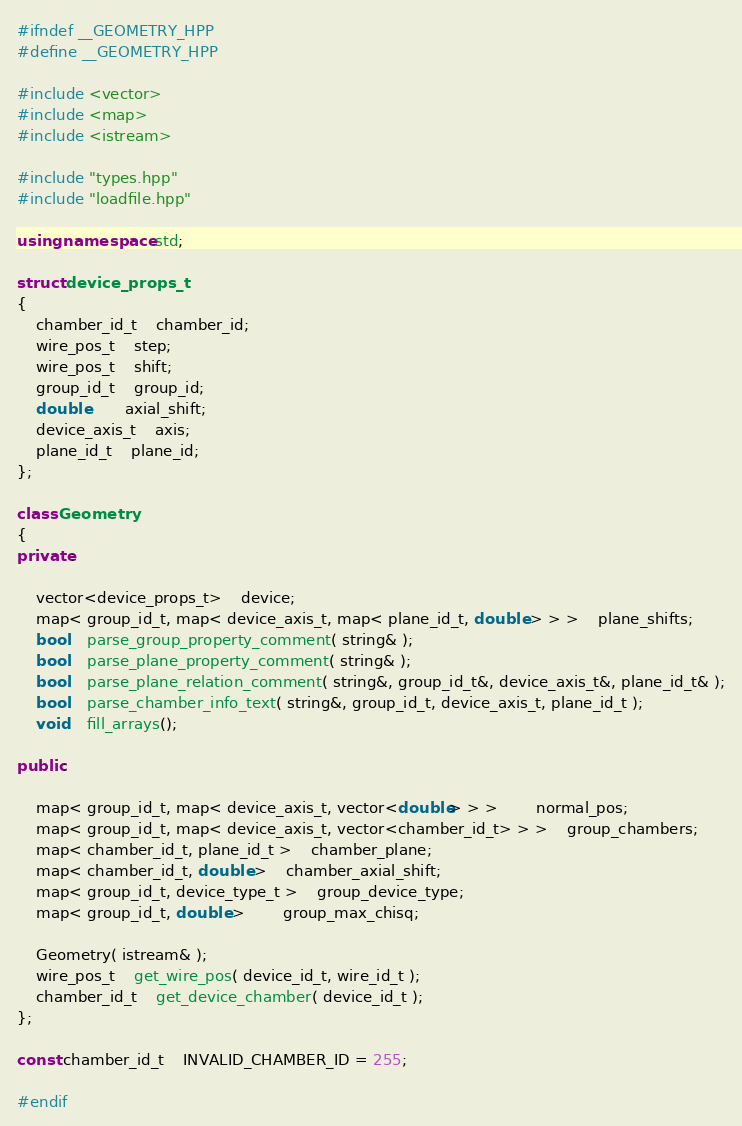<code> <loc_0><loc_0><loc_500><loc_500><_C++_>#ifndef __GEOMETRY_HPP
#define __GEOMETRY_HPP

#include <vector>
#include <map>
#include <istream>

#include "types.hpp"
#include "loadfile.hpp"

using namespace std;

struct device_props_t
{
	chamber_id_t	chamber_id;
	wire_pos_t	step;
	wire_pos_t	shift;
	group_id_t	group_id;
	double		axial_shift;
	device_axis_t	axis;
	plane_id_t	plane_id;
};

class Geometry
{
private:

	vector<device_props_t>	device;
	map< group_id_t, map< device_axis_t, map< plane_id_t, double > > >	plane_shifts;
	bool	parse_group_property_comment( string& );
	bool	parse_plane_property_comment( string& );
	bool	parse_plane_relation_comment( string&, group_id_t&, device_axis_t&, plane_id_t& );
	bool	parse_chamber_info_text( string&, group_id_t, device_axis_t, plane_id_t );
	void	fill_arrays();

public:

	map< group_id_t, map< device_axis_t, vector<double> > >		normal_pos;
	map< group_id_t, map< device_axis_t, vector<chamber_id_t> > >	group_chambers;
	map< chamber_id_t, plane_id_t >	chamber_plane;
	map< chamber_id_t, double >	chamber_axial_shift;
	map< group_id_t, device_type_t >	group_device_type;
	map< group_id_t, double >		group_max_chisq;

	Geometry( istream& );
	wire_pos_t	get_wire_pos( device_id_t, wire_id_t );
	chamber_id_t	get_device_chamber( device_id_t );
};

const chamber_id_t	INVALID_CHAMBER_ID = 255;

#endif
</code> 